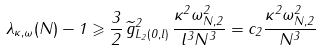Convert formula to latex. <formula><loc_0><loc_0><loc_500><loc_500>\lambda _ { \kappa , \omega } ( N ) - 1 \geqslant \frac { 3 } { 2 } \, \| \widetilde { g } \| _ { L _ { 2 } ( 0 , l ) } ^ { 2 } \, \frac { \kappa ^ { 2 } \| \omega \| _ { N , 2 } ^ { 2 } } { l ^ { 3 } N ^ { 3 } } = c _ { 2 } \frac { \kappa ^ { 2 } \| \omega \| _ { N , 2 } ^ { 2 } } { N ^ { 3 } }</formula> 